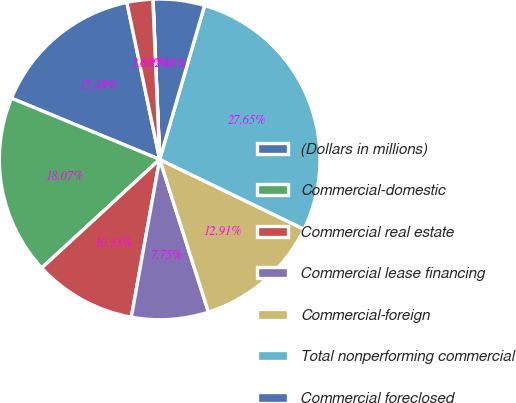Convert chart to OTSL. <chart><loc_0><loc_0><loc_500><loc_500><pie_chart><fcel>(Dollars in millions)<fcel>Commercial-domestic<fcel>Commercial real estate<fcel>Commercial lease financing<fcel>Commercial-foreign<fcel>Total nonperforming commercial<fcel>Commercial foreclosed<fcel>Nonperforming commercial loans<fcel>Nonperforming commercial<nl><fcel>15.49%<fcel>18.07%<fcel>10.33%<fcel>7.75%<fcel>12.91%<fcel>27.65%<fcel>5.18%<fcel>0.02%<fcel>2.6%<nl></chart> 